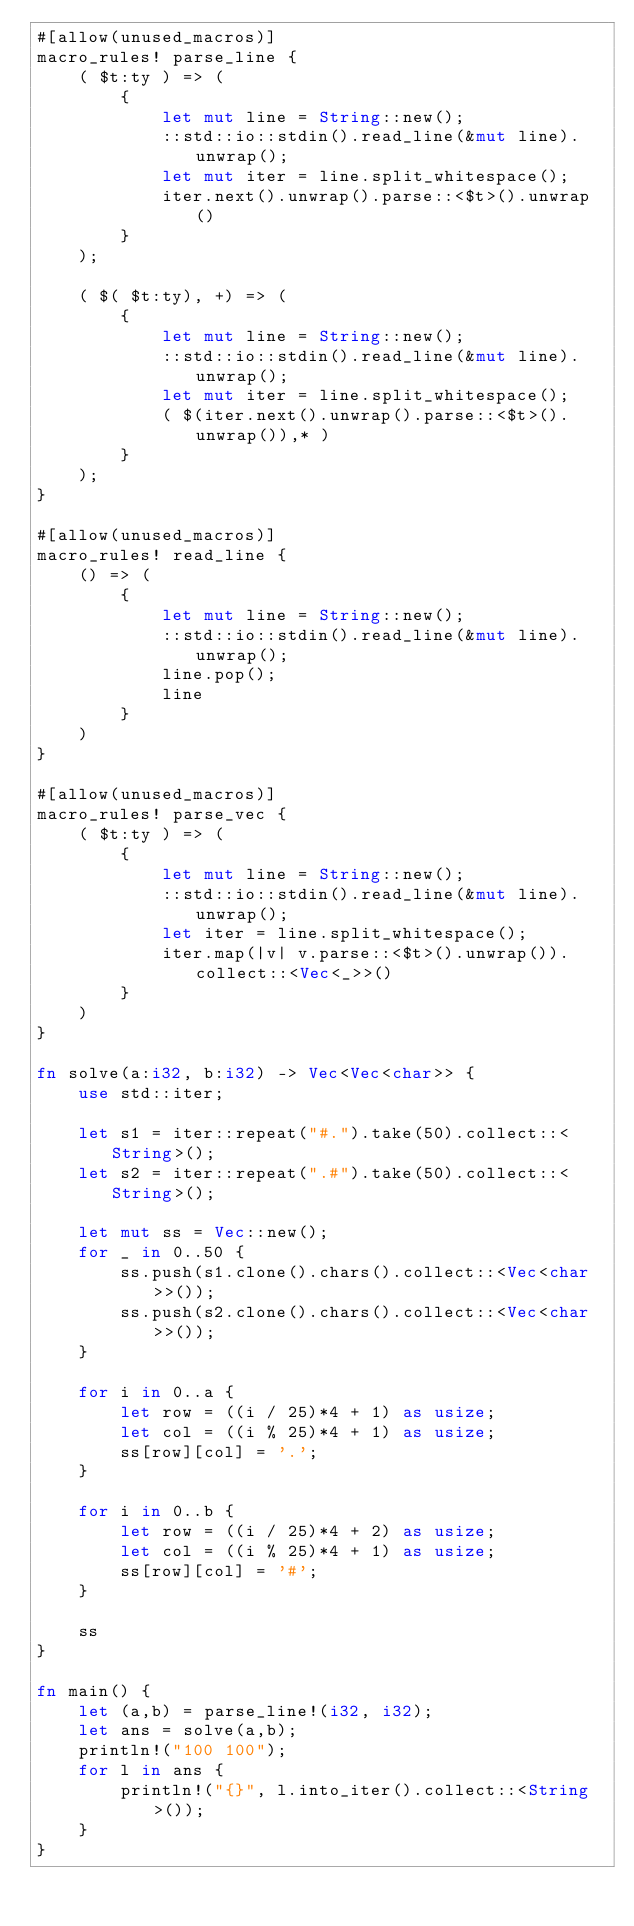<code> <loc_0><loc_0><loc_500><loc_500><_Rust_>#[allow(unused_macros)]
macro_rules! parse_line {
    ( $t:ty ) => (
        {
            let mut line = String::new();
            ::std::io::stdin().read_line(&mut line).unwrap();
            let mut iter = line.split_whitespace();
            iter.next().unwrap().parse::<$t>().unwrap()
        }
    );

    ( $( $t:ty), +) => (
        {
            let mut line = String::new();
            ::std::io::stdin().read_line(&mut line).unwrap();
            let mut iter = line.split_whitespace();
            ( $(iter.next().unwrap().parse::<$t>().unwrap()),* )
        }
    );
}

#[allow(unused_macros)]
macro_rules! read_line {
    () => (
        {
            let mut line = String::new();
            ::std::io::stdin().read_line(&mut line).unwrap();
            line.pop();
            line
        }
    )
}

#[allow(unused_macros)]
macro_rules! parse_vec {
    ( $t:ty ) => (
        {
            let mut line = String::new();
            ::std::io::stdin().read_line(&mut line).unwrap();
            let iter = line.split_whitespace();
            iter.map(|v| v.parse::<$t>().unwrap()).collect::<Vec<_>>()
        }
    )
}

fn solve(a:i32, b:i32) -> Vec<Vec<char>> {
    use std::iter;

    let s1 = iter::repeat("#.").take(50).collect::<String>();
    let s2 = iter::repeat(".#").take(50).collect::<String>();

    let mut ss = Vec::new();
    for _ in 0..50 {
        ss.push(s1.clone().chars().collect::<Vec<char>>());
        ss.push(s2.clone().chars().collect::<Vec<char>>());
    }

    for i in 0..a {
        let row = ((i / 25)*4 + 1) as usize;
        let col = ((i % 25)*4 + 1) as usize;
        ss[row][col] = '.';
    }

    for i in 0..b {
        let row = ((i / 25)*4 + 2) as usize;
        let col = ((i % 25)*4 + 1) as usize;
        ss[row][col] = '#';
    }

    ss
}

fn main() {
    let (a,b) = parse_line!(i32, i32);
    let ans = solve(a,b);
    println!("100 100");
    for l in ans {
        println!("{}", l.into_iter().collect::<String>());
    }
}
</code> 